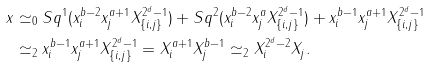<formula> <loc_0><loc_0><loc_500><loc_500>x & \simeq _ { 0 } S q ^ { 1 } ( x _ { i } ^ { b - 2 } x _ { j } ^ { a + 1 } X _ { \{ i , j \} } ^ { 2 ^ { d } - 1 } ) + S q ^ { 2 } ( x _ { i } ^ { b - 2 } x _ { j } ^ { a } X _ { \{ i , j \} } ^ { 2 ^ { d } - 1 } ) + x _ { i } ^ { b - 1 } x _ { j } ^ { a + 1 } X _ { \{ i , j \} } ^ { 2 ^ { d } - 1 } \\ & \simeq _ { 2 } x _ { i } ^ { b - 1 } x _ { j } ^ { a + 1 } X _ { \{ i , j \} } ^ { 2 ^ { d } - 1 } = X _ { i } ^ { a + 1 } X _ { j } ^ { b - 1 } \simeq _ { 2 } X _ { i } ^ { 2 ^ { d } - 2 } X _ { j } .</formula> 